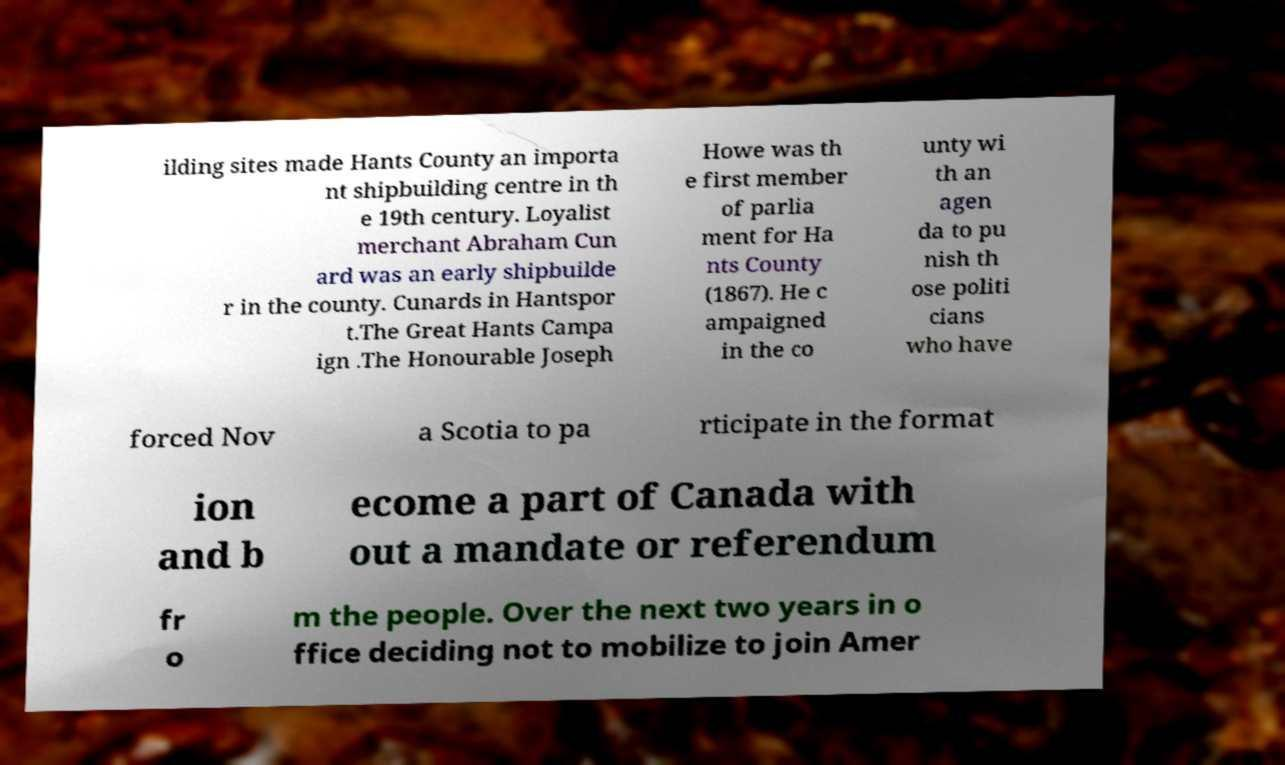There's text embedded in this image that I need extracted. Can you transcribe it verbatim? ilding sites made Hants County an importa nt shipbuilding centre in th e 19th century. Loyalist merchant Abraham Cun ard was an early shipbuilde r in the county. Cunards in Hantspor t.The Great Hants Campa ign .The Honourable Joseph Howe was th e first member of parlia ment for Ha nts County (1867). He c ampaigned in the co unty wi th an agen da to pu nish th ose politi cians who have forced Nov a Scotia to pa rticipate in the format ion and b ecome a part of Canada with out a mandate or referendum fr o m the people. Over the next two years in o ffice deciding not to mobilize to join Amer 